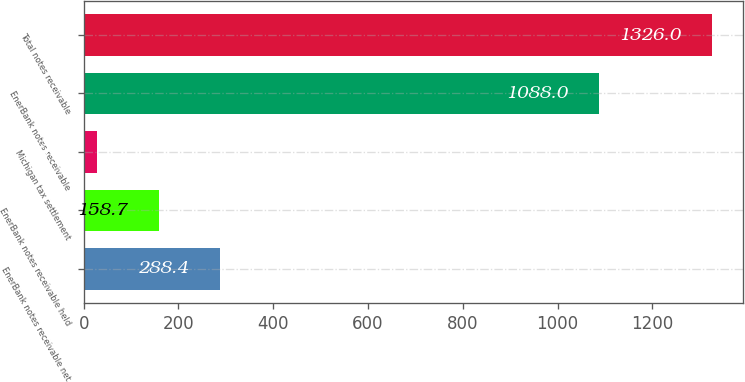Convert chart. <chart><loc_0><loc_0><loc_500><loc_500><bar_chart><fcel>EnerBank notes receivable net<fcel>EnerBank notes receivable held<fcel>Michigan tax settlement<fcel>EnerBank notes receivable<fcel>Total notes receivable<nl><fcel>288.4<fcel>158.7<fcel>29<fcel>1088<fcel>1326<nl></chart> 